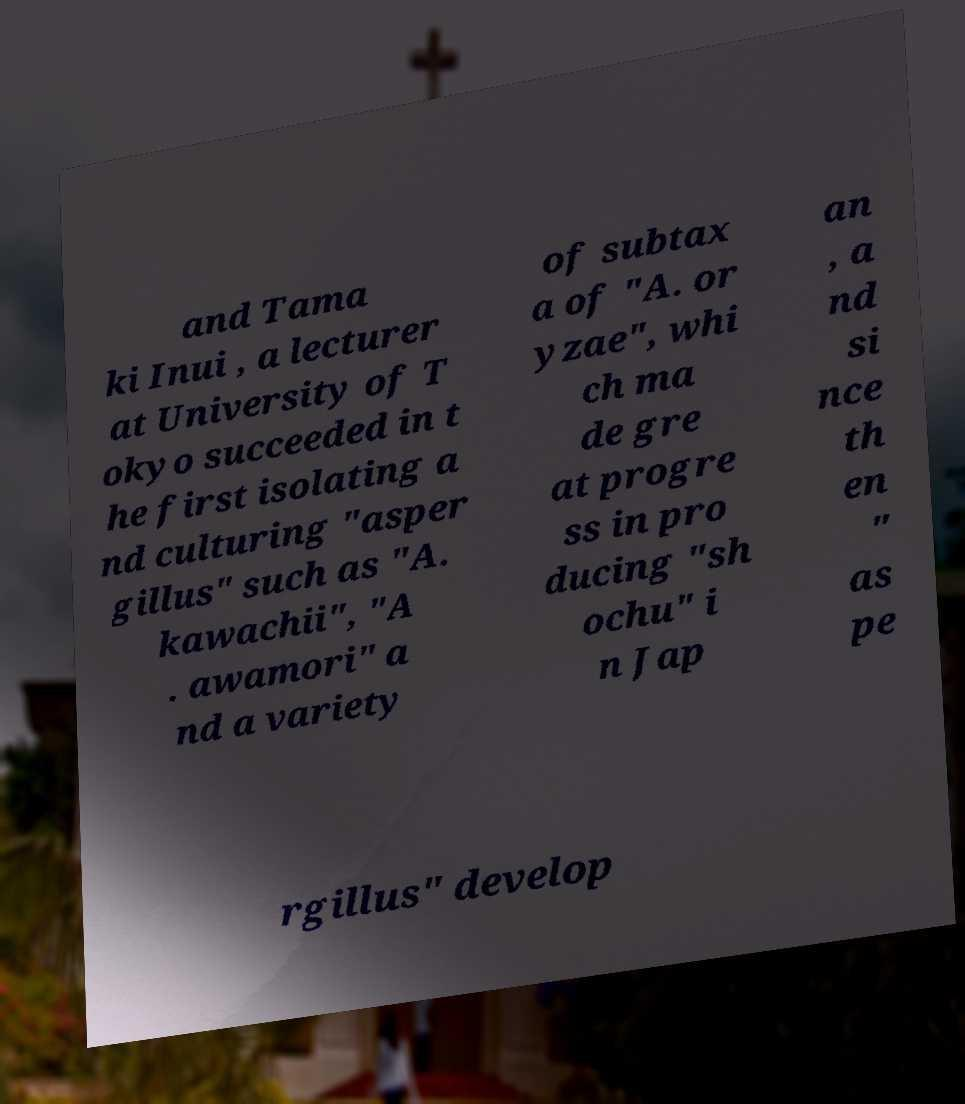Please read and relay the text visible in this image. What does it say? and Tama ki Inui , a lecturer at University of T okyo succeeded in t he first isolating a nd culturing "asper gillus" such as "A. kawachii", "A . awamori" a nd a variety of subtax a of "A. or yzae", whi ch ma de gre at progre ss in pro ducing "sh ochu" i n Jap an , a nd si nce th en " as pe rgillus" develop 